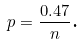<formula> <loc_0><loc_0><loc_500><loc_500>p = \frac { 0 . 4 7 } { n } \text {.}</formula> 